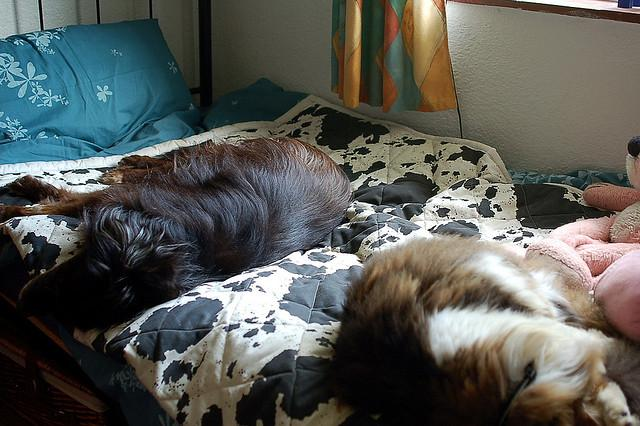Who is the bed for?

Choices:
A) human
B) rhino
C) elephant
D) dogs human 